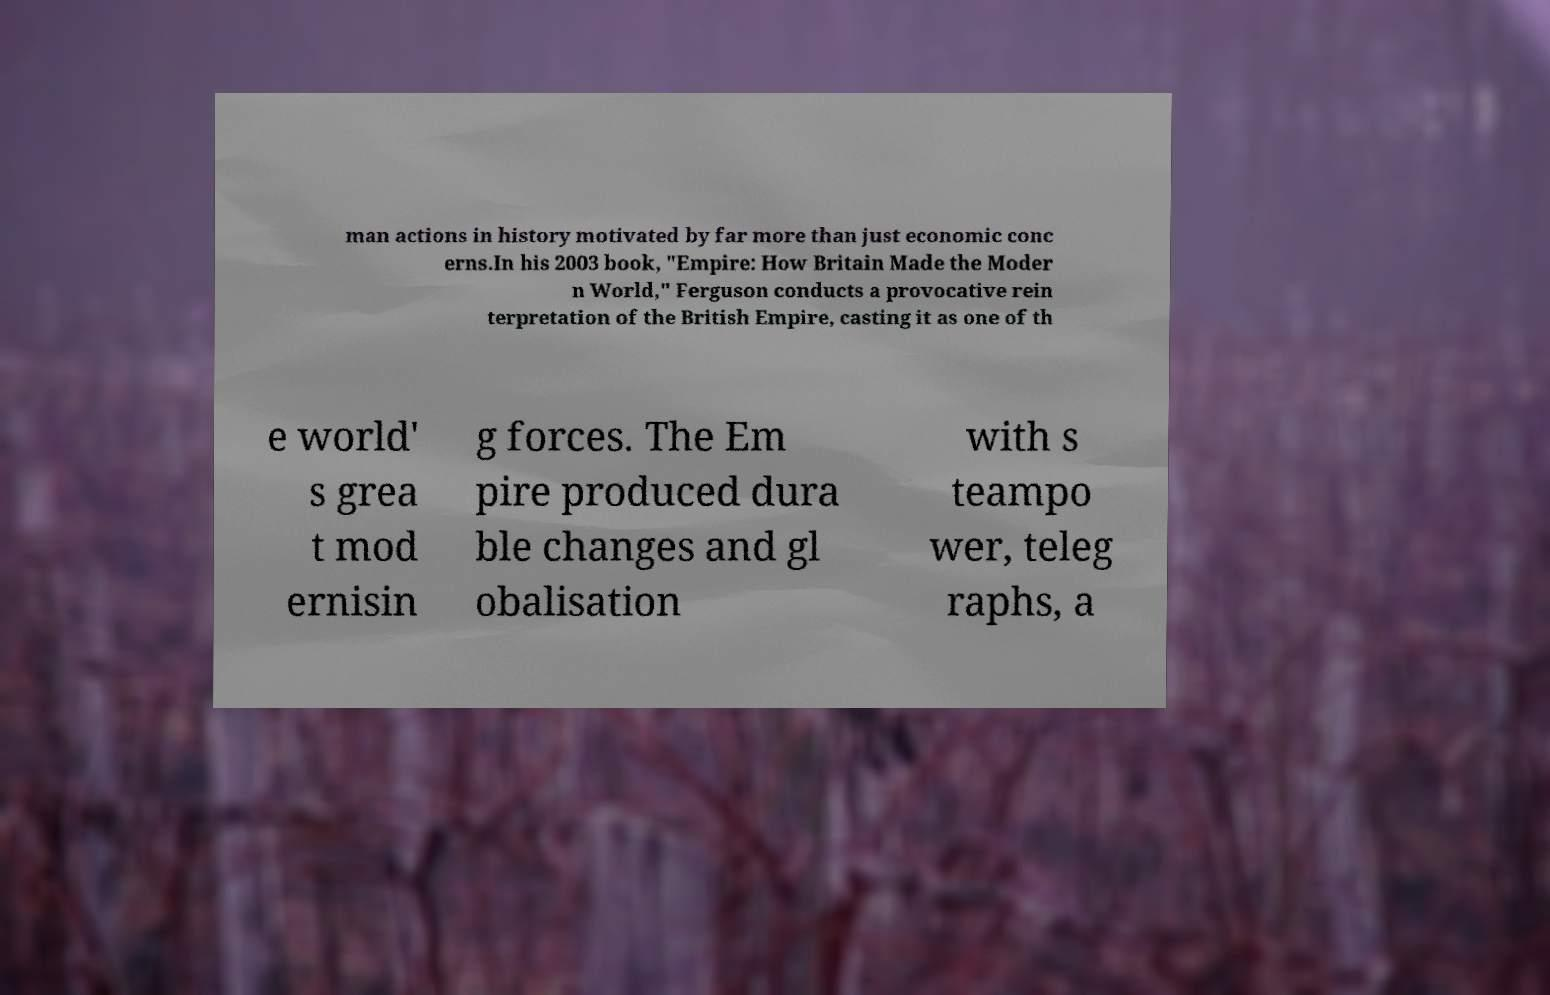Please identify and transcribe the text found in this image. man actions in history motivated by far more than just economic conc erns.In his 2003 book, "Empire: How Britain Made the Moder n World," Ferguson conducts a provocative rein terpretation of the British Empire, casting it as one of th e world' s grea t mod ernisin g forces. The Em pire produced dura ble changes and gl obalisation with s teampo wer, teleg raphs, a 